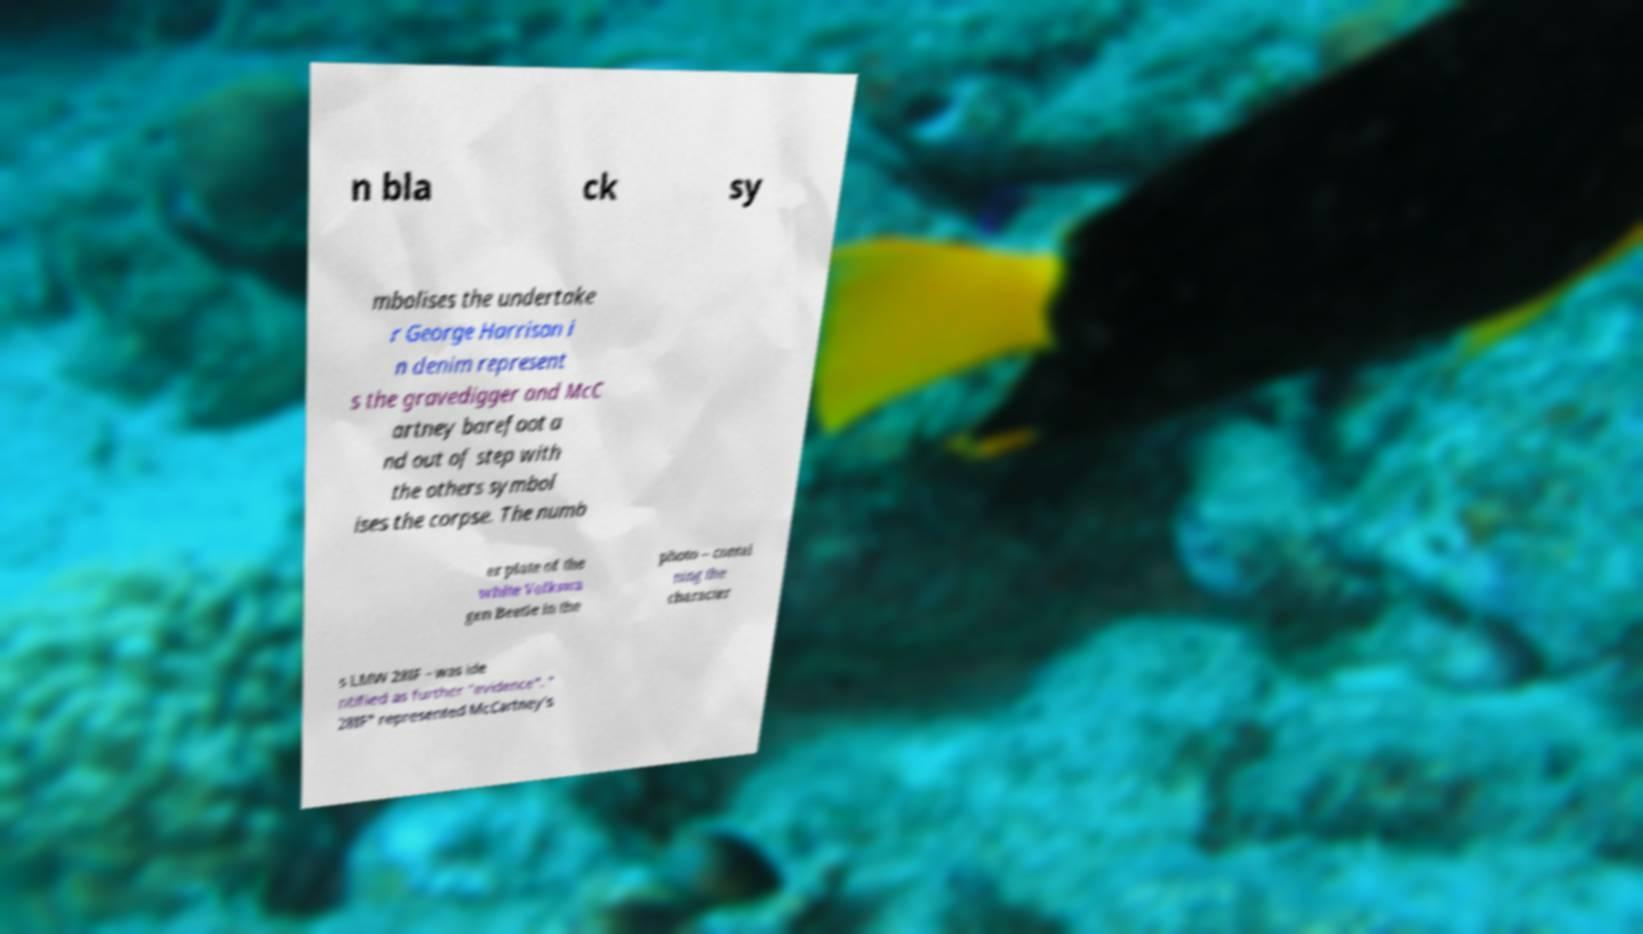For documentation purposes, I need the text within this image transcribed. Could you provide that? n bla ck sy mbolises the undertake r George Harrison i n denim represent s the gravedigger and McC artney barefoot a nd out of step with the others symbol ises the corpse. The numb er plate of the white Volkswa gen Beetle in the photo – contai ning the character s LMW 28IF – was ide ntified as further "evidence". " 28IF" represented McCartney's 